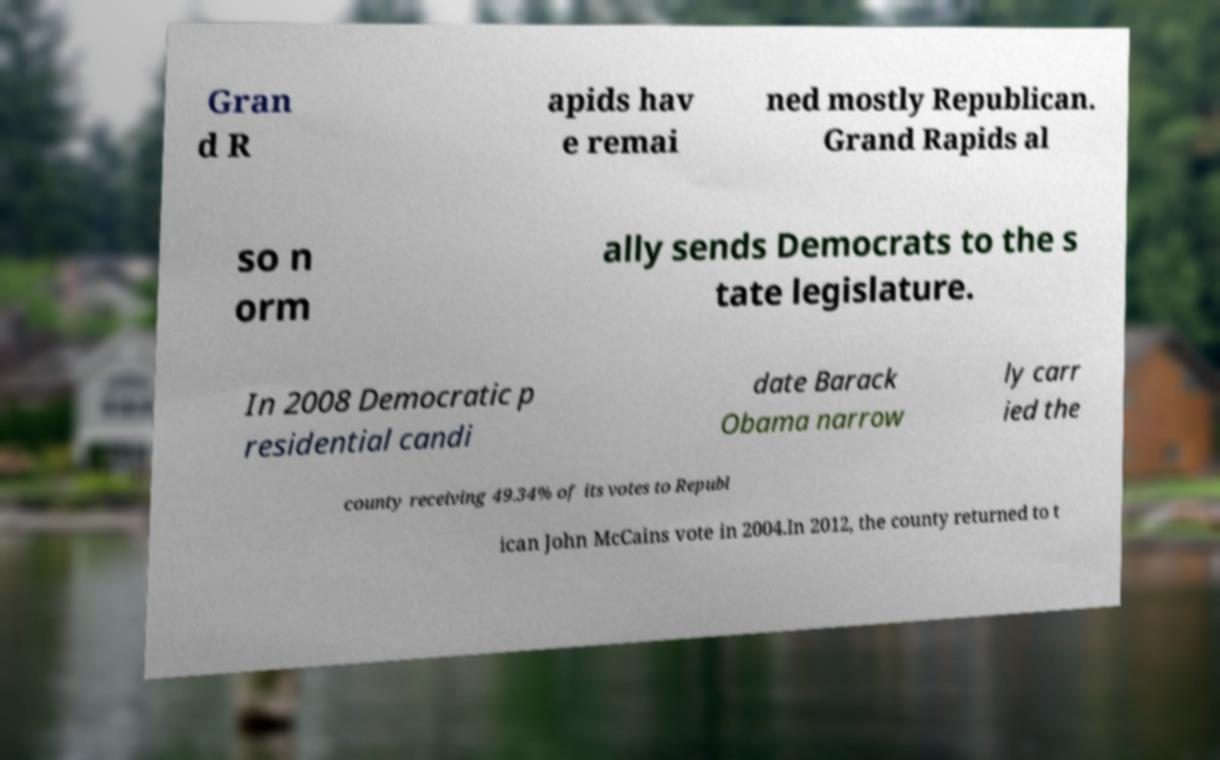Please identify and transcribe the text found in this image. Gran d R apids hav e remai ned mostly Republican. Grand Rapids al so n orm ally sends Democrats to the s tate legislature. In 2008 Democratic p residential candi date Barack Obama narrow ly carr ied the county receiving 49.34% of its votes to Republ ican John McCains vote in 2004.In 2012, the county returned to t 